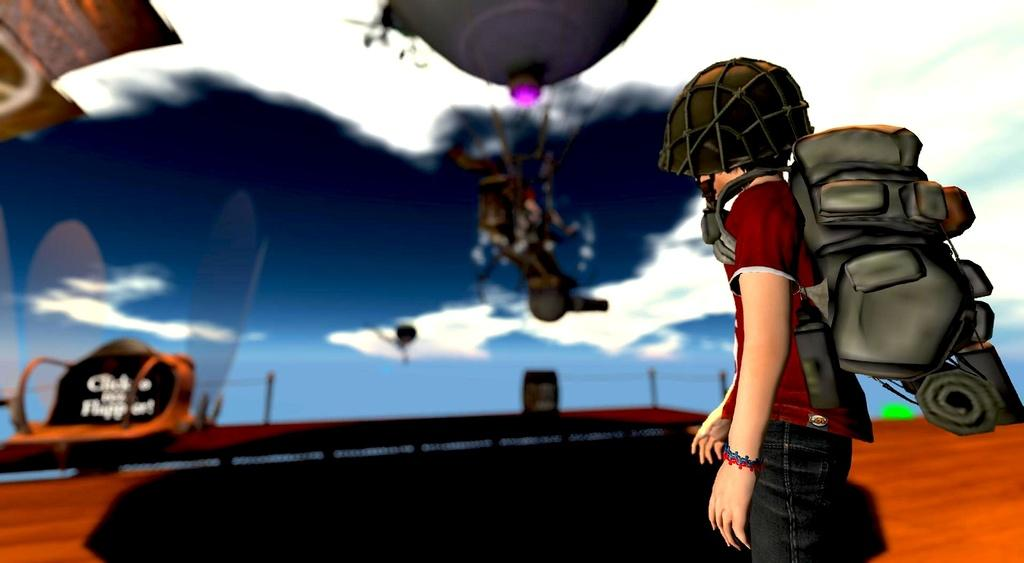What is the main subject of the image? There is a person in the image. What is the person wearing? The person is wearing a backpack. What is the person's posture in the image? The person is standing. Can you describe any other objects present in the image? There are other objects present in the image, but their specific details are not mentioned in the provided facts. How many cattle can be seen grazing in the background of the image? There is no mention of cattle or any background in the provided facts, so it cannot be determined from the image. 